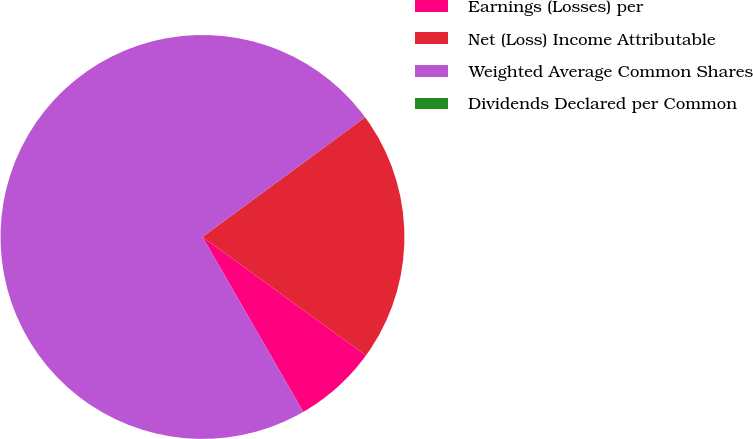Convert chart. <chart><loc_0><loc_0><loc_500><loc_500><pie_chart><fcel>Earnings (Losses) per<fcel>Net (Loss) Income Attributable<fcel>Weighted Average Common Shares<fcel>Dividends Declared per Common<nl><fcel>6.69%<fcel>20.08%<fcel>73.23%<fcel>0.0%<nl></chart> 